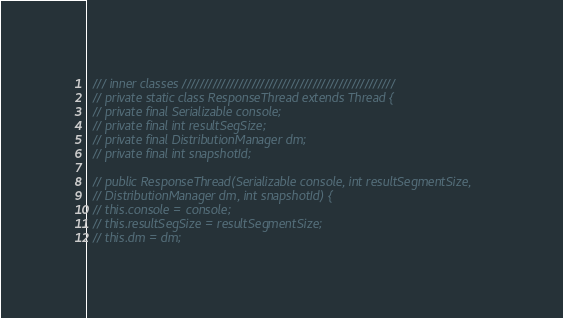<code> <loc_0><loc_0><loc_500><loc_500><_Java_>  /// inner classes /////////////////////////////////////////////////
  // private static class ResponseThread extends Thread {
  // private final Serializable console;
  // private final int resultSegSize;
  // private final DistributionManager dm;
  // private final int snapshotId;

  // public ResponseThread(Serializable console, int resultSegmentSize,
  // DistributionManager dm, int snapshotId) {
  // this.console = console;
  // this.resultSegSize = resultSegmentSize;
  // this.dm = dm;</code> 